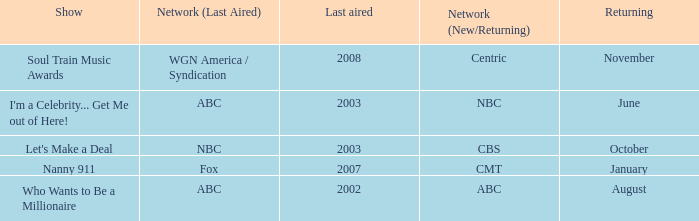When did soul train music awards return? November. 